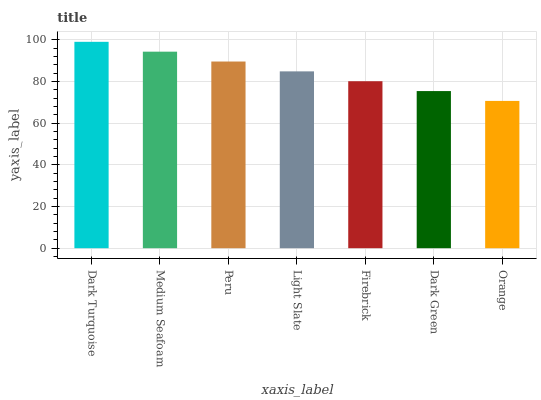Is Orange the minimum?
Answer yes or no. Yes. Is Dark Turquoise the maximum?
Answer yes or no. Yes. Is Medium Seafoam the minimum?
Answer yes or no. No. Is Medium Seafoam the maximum?
Answer yes or no. No. Is Dark Turquoise greater than Medium Seafoam?
Answer yes or no. Yes. Is Medium Seafoam less than Dark Turquoise?
Answer yes or no. Yes. Is Medium Seafoam greater than Dark Turquoise?
Answer yes or no. No. Is Dark Turquoise less than Medium Seafoam?
Answer yes or no. No. Is Light Slate the high median?
Answer yes or no. Yes. Is Light Slate the low median?
Answer yes or no. Yes. Is Orange the high median?
Answer yes or no. No. Is Dark Turquoise the low median?
Answer yes or no. No. 